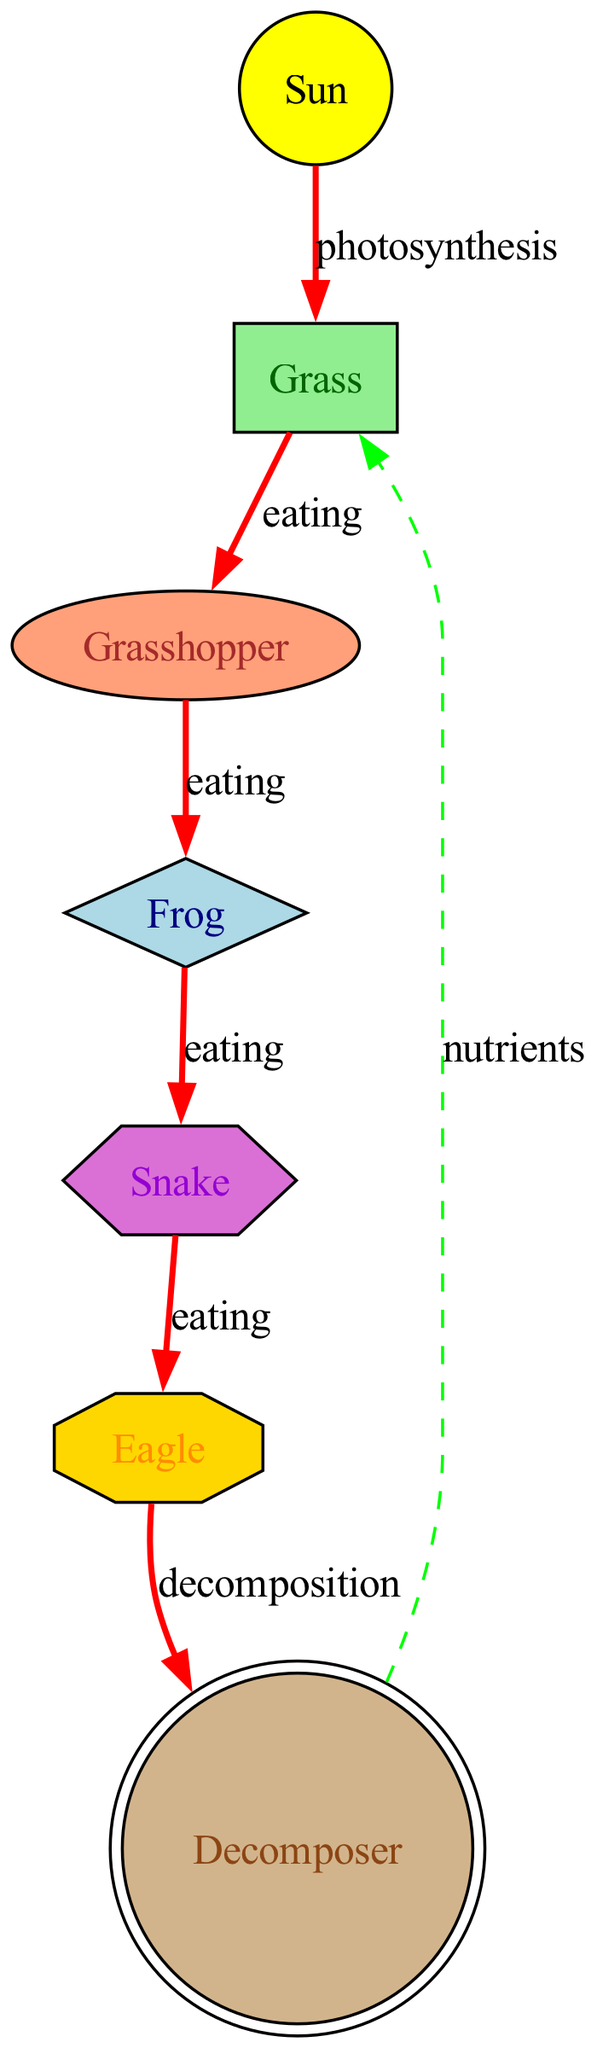What is the source of energy in this food web? The diagram starts with the Sun, which is labeled as the source of energy. This is indicated by the "source" type assigned to it.
Answer: Sun How many producers are present in the diagram? The diagram includes one producer, which is Grass, as seen in the node count with the "producer" type.
Answer: 1 Which consumer directly eats the Grasshopper? The Grasshopper is directly eaten by the Frog, indicated by the edge labeled "eating" that connects them, showing the flow of energy.
Answer: Frog What type of consumer is the Eagle? The Eagle is classified as a quaternary consumer, as specified in the node's type designation and its position in the energy flow hierarchy.
Answer: Quaternary consumer What process allows Grass to convert sunlight into energy? The edge between the Sun and Grass is labeled "photosynthesis," which explains how the Grass uses sunlight to produce energy.
Answer: Photosynthesis Which organism is classified as a decomposer? The Decomposer is clearly labeled in the diagram and serves to recycle nutrients back into the ecosystem.
Answer: Decomposer How does energy flow from the Snake to the Decomposer? The energy flow from the Snake to the Decomposer occurs through the edge labeled "decomposition," indicating that when the Eagle decomposes, it transfers energy to the Decomposer.
Answer: Decomposition What is the label on the edge between the Frog and the Snake? The edge connecting the Frog and the Snake is labeled "eating," which specifies the interaction between these two consumers in the energy flow sequence.
Answer: Eating How do Decomposers affect the Grass? Decomposers contribute nutrients back to the Grass, as indicated by the edge labeled "nutrients" that connects the Decomposer back to the Grass.
Answer: Nutrients 